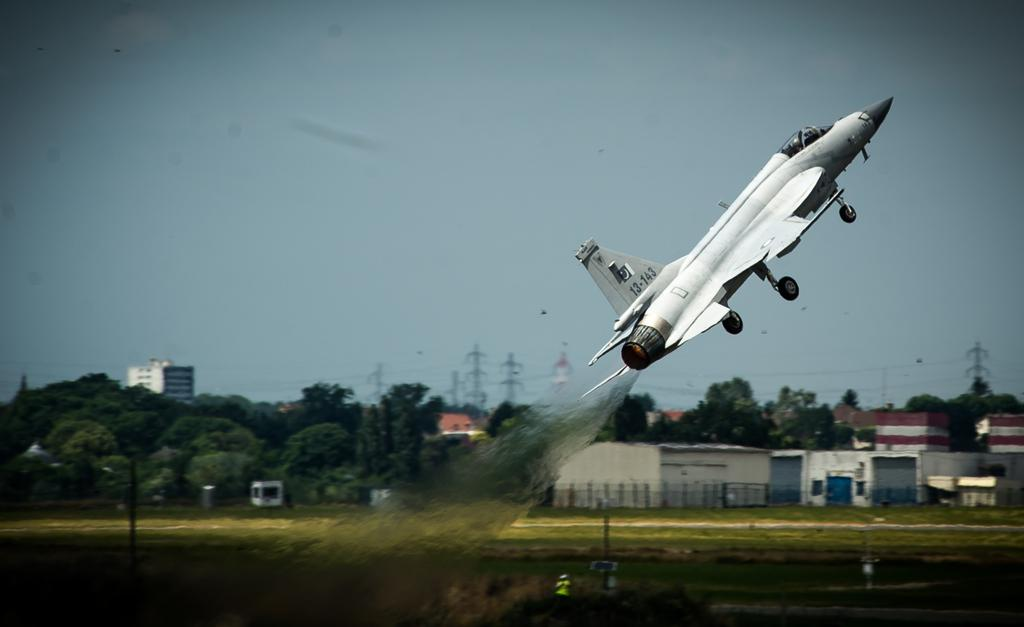<image>
Offer a succinct explanation of the picture presented. A military plane with call numbers 13-143 shoots up into the air. 